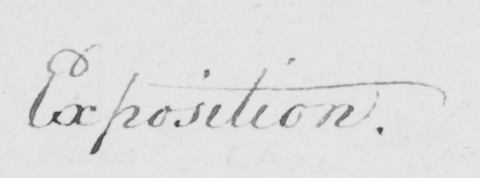Please transcribe the handwritten text in this image. Exposition. 